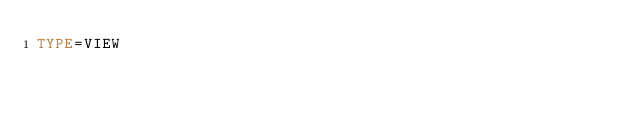Convert code to text. <code><loc_0><loc_0><loc_500><loc_500><_VisualBasic_>TYPE=VIEW</code> 